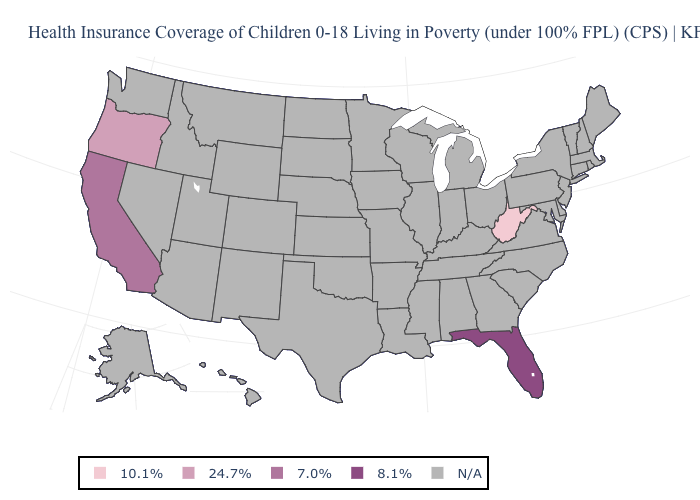Which states hav the highest value in the West?
Write a very short answer. California. What is the value of Vermont?
Write a very short answer. N/A. Which states have the lowest value in the South?
Write a very short answer. West Virginia. Does Oregon have the highest value in the USA?
Write a very short answer. No. Among the states that border Nevada , does California have the highest value?
Give a very brief answer. Yes. How many symbols are there in the legend?
Give a very brief answer. 5. Name the states that have a value in the range 10.1%?
Keep it brief. West Virginia. 